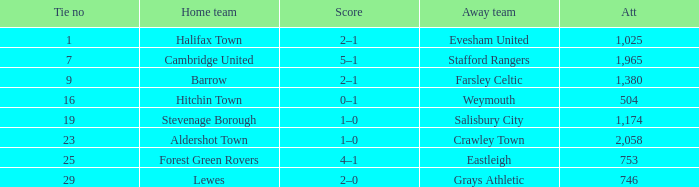Who was the away team in a tie no larger than 16 with forest green rovers at home? Eastleigh. 